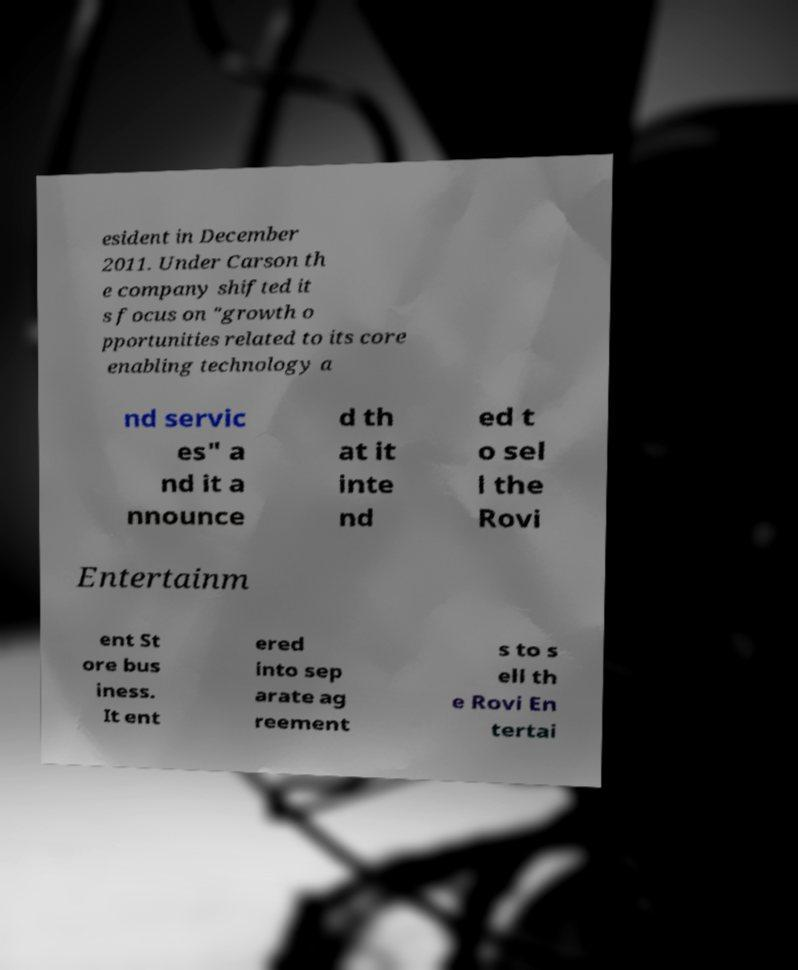Can you accurately transcribe the text from the provided image for me? esident in December 2011. Under Carson th e company shifted it s focus on "growth o pportunities related to its core enabling technology a nd servic es" a nd it a nnounce d th at it inte nd ed t o sel l the Rovi Entertainm ent St ore bus iness. It ent ered into sep arate ag reement s to s ell th e Rovi En tertai 